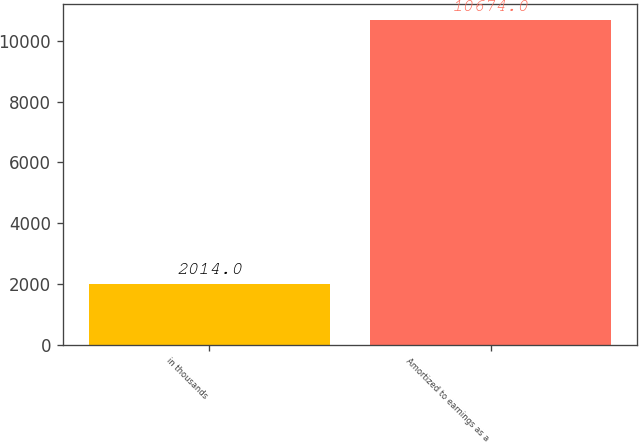<chart> <loc_0><loc_0><loc_500><loc_500><bar_chart><fcel>in thousands<fcel>Amortized to earnings as a<nl><fcel>2014<fcel>10674<nl></chart> 